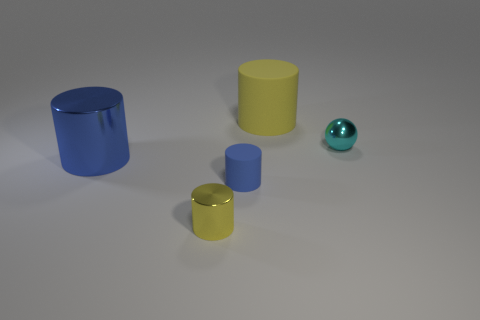What number of green blocks are there? 0 